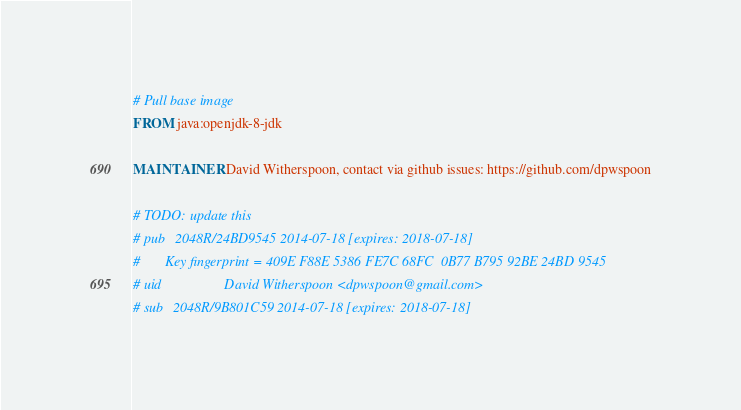Convert code to text. <code><loc_0><loc_0><loc_500><loc_500><_Dockerfile_># Pull base image
FROM java:openjdk-8-jdk

MAINTAINER David Witherspoon, contact via github issues: https://github.com/dpwspoon

# TODO: update this
# pub   2048R/24BD9545 2014-07-18 [expires: 2018-07-18]
#       Key fingerprint = 409E F88E 5386 FE7C 68FC  0B77 B795 92BE 24BD 9545
# uid                  David Witherspoon <dpwspoon@gmail.com>
# sub   2048R/9B801C59 2014-07-18 [expires: 2018-07-18]</code> 